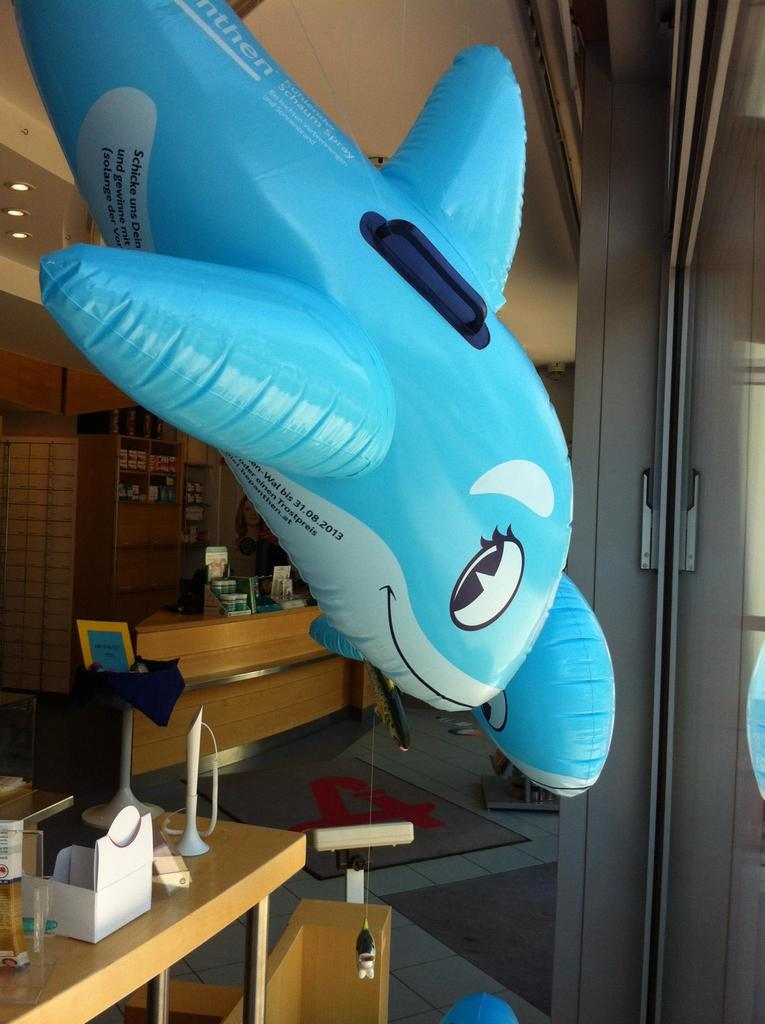<image>
Present a compact description of the photo's key features. A blue inflatable whale with the date 31/08/20 on its white belly 